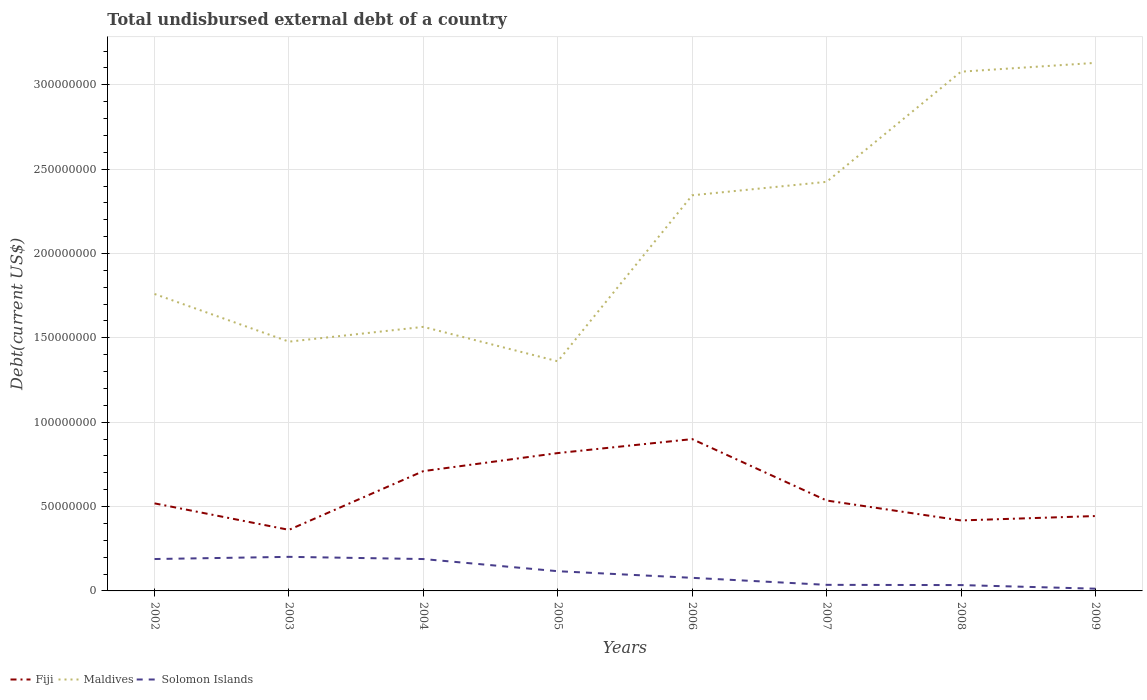Does the line corresponding to Maldives intersect with the line corresponding to Fiji?
Provide a succinct answer. No. Is the number of lines equal to the number of legend labels?
Keep it short and to the point. Yes. Across all years, what is the maximum total undisbursed external debt in Maldives?
Offer a very short reply. 1.36e+08. What is the total total undisbursed external debt in Solomon Islands in the graph?
Provide a short and direct response. -1.30e+06. What is the difference between the highest and the second highest total undisbursed external debt in Maldives?
Keep it short and to the point. 1.77e+08. Is the total undisbursed external debt in Maldives strictly greater than the total undisbursed external debt in Fiji over the years?
Give a very brief answer. No. How many lines are there?
Offer a very short reply. 3. What is the difference between two consecutive major ticks on the Y-axis?
Your answer should be very brief. 5.00e+07. Are the values on the major ticks of Y-axis written in scientific E-notation?
Keep it short and to the point. No. Does the graph contain grids?
Your response must be concise. Yes. What is the title of the graph?
Ensure brevity in your answer.  Total undisbursed external debt of a country. What is the label or title of the Y-axis?
Provide a short and direct response. Debt(current US$). What is the Debt(current US$) in Fiji in 2002?
Provide a succinct answer. 5.19e+07. What is the Debt(current US$) in Maldives in 2002?
Your answer should be very brief. 1.76e+08. What is the Debt(current US$) in Solomon Islands in 2002?
Offer a terse response. 1.89e+07. What is the Debt(current US$) of Fiji in 2003?
Keep it short and to the point. 3.62e+07. What is the Debt(current US$) in Maldives in 2003?
Make the answer very short. 1.48e+08. What is the Debt(current US$) of Solomon Islands in 2003?
Make the answer very short. 2.02e+07. What is the Debt(current US$) in Fiji in 2004?
Offer a very short reply. 7.10e+07. What is the Debt(current US$) in Maldives in 2004?
Offer a terse response. 1.57e+08. What is the Debt(current US$) of Solomon Islands in 2004?
Keep it short and to the point. 1.89e+07. What is the Debt(current US$) of Fiji in 2005?
Keep it short and to the point. 8.17e+07. What is the Debt(current US$) of Maldives in 2005?
Make the answer very short. 1.36e+08. What is the Debt(current US$) of Solomon Islands in 2005?
Your response must be concise. 1.17e+07. What is the Debt(current US$) of Fiji in 2006?
Keep it short and to the point. 9.00e+07. What is the Debt(current US$) in Maldives in 2006?
Keep it short and to the point. 2.35e+08. What is the Debt(current US$) of Solomon Islands in 2006?
Your response must be concise. 7.76e+06. What is the Debt(current US$) in Fiji in 2007?
Provide a succinct answer. 5.36e+07. What is the Debt(current US$) of Maldives in 2007?
Give a very brief answer. 2.42e+08. What is the Debt(current US$) of Solomon Islands in 2007?
Your answer should be compact. 3.60e+06. What is the Debt(current US$) of Fiji in 2008?
Provide a succinct answer. 4.18e+07. What is the Debt(current US$) in Maldives in 2008?
Offer a terse response. 3.08e+08. What is the Debt(current US$) of Solomon Islands in 2008?
Provide a short and direct response. 3.46e+06. What is the Debt(current US$) of Fiji in 2009?
Provide a succinct answer. 4.44e+07. What is the Debt(current US$) in Maldives in 2009?
Keep it short and to the point. 3.13e+08. What is the Debt(current US$) of Solomon Islands in 2009?
Keep it short and to the point. 1.32e+06. Across all years, what is the maximum Debt(current US$) of Fiji?
Provide a succinct answer. 9.00e+07. Across all years, what is the maximum Debt(current US$) of Maldives?
Your answer should be very brief. 3.13e+08. Across all years, what is the maximum Debt(current US$) in Solomon Islands?
Your answer should be very brief. 2.02e+07. Across all years, what is the minimum Debt(current US$) in Fiji?
Your answer should be very brief. 3.62e+07. Across all years, what is the minimum Debt(current US$) of Maldives?
Ensure brevity in your answer.  1.36e+08. Across all years, what is the minimum Debt(current US$) in Solomon Islands?
Ensure brevity in your answer.  1.32e+06. What is the total Debt(current US$) in Fiji in the graph?
Ensure brevity in your answer.  4.71e+08. What is the total Debt(current US$) of Maldives in the graph?
Offer a very short reply. 1.71e+09. What is the total Debt(current US$) in Solomon Islands in the graph?
Offer a very short reply. 8.58e+07. What is the difference between the Debt(current US$) in Fiji in 2002 and that in 2003?
Your answer should be compact. 1.57e+07. What is the difference between the Debt(current US$) of Maldives in 2002 and that in 2003?
Your answer should be compact. 2.83e+07. What is the difference between the Debt(current US$) of Solomon Islands in 2002 and that in 2003?
Your response must be concise. -1.30e+06. What is the difference between the Debt(current US$) of Fiji in 2002 and that in 2004?
Offer a terse response. -1.91e+07. What is the difference between the Debt(current US$) of Maldives in 2002 and that in 2004?
Provide a succinct answer. 1.95e+07. What is the difference between the Debt(current US$) of Solomon Islands in 2002 and that in 2004?
Offer a very short reply. 9000. What is the difference between the Debt(current US$) in Fiji in 2002 and that in 2005?
Your answer should be compact. -2.98e+07. What is the difference between the Debt(current US$) of Maldives in 2002 and that in 2005?
Provide a short and direct response. 3.99e+07. What is the difference between the Debt(current US$) in Solomon Islands in 2002 and that in 2005?
Ensure brevity in your answer.  7.22e+06. What is the difference between the Debt(current US$) in Fiji in 2002 and that in 2006?
Make the answer very short. -3.81e+07. What is the difference between the Debt(current US$) in Maldives in 2002 and that in 2006?
Your answer should be compact. -5.85e+07. What is the difference between the Debt(current US$) in Solomon Islands in 2002 and that in 2006?
Provide a short and direct response. 1.11e+07. What is the difference between the Debt(current US$) of Fiji in 2002 and that in 2007?
Offer a very short reply. -1.69e+06. What is the difference between the Debt(current US$) of Maldives in 2002 and that in 2007?
Provide a short and direct response. -6.65e+07. What is the difference between the Debt(current US$) in Solomon Islands in 2002 and that in 2007?
Make the answer very short. 1.53e+07. What is the difference between the Debt(current US$) in Fiji in 2002 and that in 2008?
Offer a very short reply. 1.01e+07. What is the difference between the Debt(current US$) of Maldives in 2002 and that in 2008?
Offer a very short reply. -1.32e+08. What is the difference between the Debt(current US$) of Solomon Islands in 2002 and that in 2008?
Ensure brevity in your answer.  1.54e+07. What is the difference between the Debt(current US$) in Fiji in 2002 and that in 2009?
Offer a very short reply. 7.51e+06. What is the difference between the Debt(current US$) in Maldives in 2002 and that in 2009?
Give a very brief answer. -1.37e+08. What is the difference between the Debt(current US$) of Solomon Islands in 2002 and that in 2009?
Keep it short and to the point. 1.76e+07. What is the difference between the Debt(current US$) in Fiji in 2003 and that in 2004?
Offer a very short reply. -3.48e+07. What is the difference between the Debt(current US$) in Maldives in 2003 and that in 2004?
Make the answer very short. -8.77e+06. What is the difference between the Debt(current US$) in Solomon Islands in 2003 and that in 2004?
Make the answer very short. 1.30e+06. What is the difference between the Debt(current US$) in Fiji in 2003 and that in 2005?
Your answer should be compact. -4.55e+07. What is the difference between the Debt(current US$) in Maldives in 2003 and that in 2005?
Keep it short and to the point. 1.16e+07. What is the difference between the Debt(current US$) in Solomon Islands in 2003 and that in 2005?
Make the answer very short. 8.52e+06. What is the difference between the Debt(current US$) of Fiji in 2003 and that in 2006?
Your response must be concise. -5.38e+07. What is the difference between the Debt(current US$) in Maldives in 2003 and that in 2006?
Make the answer very short. -8.68e+07. What is the difference between the Debt(current US$) of Solomon Islands in 2003 and that in 2006?
Provide a short and direct response. 1.24e+07. What is the difference between the Debt(current US$) of Fiji in 2003 and that in 2007?
Give a very brief answer. -1.74e+07. What is the difference between the Debt(current US$) of Maldives in 2003 and that in 2007?
Ensure brevity in your answer.  -9.47e+07. What is the difference between the Debt(current US$) in Solomon Islands in 2003 and that in 2007?
Provide a short and direct response. 1.66e+07. What is the difference between the Debt(current US$) of Fiji in 2003 and that in 2008?
Provide a succinct answer. -5.58e+06. What is the difference between the Debt(current US$) of Maldives in 2003 and that in 2008?
Ensure brevity in your answer.  -1.60e+08. What is the difference between the Debt(current US$) in Solomon Islands in 2003 and that in 2008?
Provide a succinct answer. 1.67e+07. What is the difference between the Debt(current US$) of Fiji in 2003 and that in 2009?
Your answer should be very brief. -8.18e+06. What is the difference between the Debt(current US$) in Maldives in 2003 and that in 2009?
Offer a very short reply. -1.65e+08. What is the difference between the Debt(current US$) of Solomon Islands in 2003 and that in 2009?
Give a very brief answer. 1.89e+07. What is the difference between the Debt(current US$) in Fiji in 2004 and that in 2005?
Your response must be concise. -1.07e+07. What is the difference between the Debt(current US$) in Maldives in 2004 and that in 2005?
Keep it short and to the point. 2.04e+07. What is the difference between the Debt(current US$) in Solomon Islands in 2004 and that in 2005?
Keep it short and to the point. 7.21e+06. What is the difference between the Debt(current US$) in Fiji in 2004 and that in 2006?
Offer a terse response. -1.90e+07. What is the difference between the Debt(current US$) in Maldives in 2004 and that in 2006?
Your answer should be compact. -7.80e+07. What is the difference between the Debt(current US$) of Solomon Islands in 2004 and that in 2006?
Your response must be concise. 1.11e+07. What is the difference between the Debt(current US$) in Fiji in 2004 and that in 2007?
Ensure brevity in your answer.  1.74e+07. What is the difference between the Debt(current US$) of Maldives in 2004 and that in 2007?
Your answer should be very brief. -8.60e+07. What is the difference between the Debt(current US$) of Solomon Islands in 2004 and that in 2007?
Make the answer very short. 1.53e+07. What is the difference between the Debt(current US$) in Fiji in 2004 and that in 2008?
Make the answer very short. 2.92e+07. What is the difference between the Debt(current US$) in Maldives in 2004 and that in 2008?
Offer a very short reply. -1.51e+08. What is the difference between the Debt(current US$) in Solomon Islands in 2004 and that in 2008?
Your response must be concise. 1.54e+07. What is the difference between the Debt(current US$) of Fiji in 2004 and that in 2009?
Your answer should be compact. 2.66e+07. What is the difference between the Debt(current US$) of Maldives in 2004 and that in 2009?
Keep it short and to the point. -1.56e+08. What is the difference between the Debt(current US$) in Solomon Islands in 2004 and that in 2009?
Offer a very short reply. 1.76e+07. What is the difference between the Debt(current US$) in Fiji in 2005 and that in 2006?
Make the answer very short. -8.28e+06. What is the difference between the Debt(current US$) of Maldives in 2005 and that in 2006?
Your answer should be compact. -9.84e+07. What is the difference between the Debt(current US$) in Solomon Islands in 2005 and that in 2006?
Keep it short and to the point. 3.92e+06. What is the difference between the Debt(current US$) in Fiji in 2005 and that in 2007?
Provide a succinct answer. 2.81e+07. What is the difference between the Debt(current US$) in Maldives in 2005 and that in 2007?
Keep it short and to the point. -1.06e+08. What is the difference between the Debt(current US$) in Solomon Islands in 2005 and that in 2007?
Keep it short and to the point. 8.08e+06. What is the difference between the Debt(current US$) of Fiji in 2005 and that in 2008?
Offer a very short reply. 3.99e+07. What is the difference between the Debt(current US$) in Maldives in 2005 and that in 2008?
Make the answer very short. -1.72e+08. What is the difference between the Debt(current US$) of Solomon Islands in 2005 and that in 2008?
Make the answer very short. 8.22e+06. What is the difference between the Debt(current US$) of Fiji in 2005 and that in 2009?
Provide a succinct answer. 3.73e+07. What is the difference between the Debt(current US$) in Maldives in 2005 and that in 2009?
Offer a terse response. -1.77e+08. What is the difference between the Debt(current US$) of Solomon Islands in 2005 and that in 2009?
Give a very brief answer. 1.04e+07. What is the difference between the Debt(current US$) in Fiji in 2006 and that in 2007?
Provide a short and direct response. 3.64e+07. What is the difference between the Debt(current US$) of Maldives in 2006 and that in 2007?
Keep it short and to the point. -7.98e+06. What is the difference between the Debt(current US$) in Solomon Islands in 2006 and that in 2007?
Your response must be concise. 4.16e+06. What is the difference between the Debt(current US$) of Fiji in 2006 and that in 2008?
Your answer should be very brief. 4.82e+07. What is the difference between the Debt(current US$) of Maldives in 2006 and that in 2008?
Provide a succinct answer. -7.33e+07. What is the difference between the Debt(current US$) of Solomon Islands in 2006 and that in 2008?
Provide a short and direct response. 4.30e+06. What is the difference between the Debt(current US$) of Fiji in 2006 and that in 2009?
Give a very brief answer. 4.56e+07. What is the difference between the Debt(current US$) of Maldives in 2006 and that in 2009?
Offer a terse response. -7.85e+07. What is the difference between the Debt(current US$) in Solomon Islands in 2006 and that in 2009?
Your answer should be compact. 6.44e+06. What is the difference between the Debt(current US$) of Fiji in 2007 and that in 2008?
Make the answer very short. 1.18e+07. What is the difference between the Debt(current US$) in Maldives in 2007 and that in 2008?
Make the answer very short. -6.53e+07. What is the difference between the Debt(current US$) in Solomon Islands in 2007 and that in 2008?
Offer a very short reply. 1.39e+05. What is the difference between the Debt(current US$) of Fiji in 2007 and that in 2009?
Your response must be concise. 9.20e+06. What is the difference between the Debt(current US$) of Maldives in 2007 and that in 2009?
Offer a very short reply. -7.05e+07. What is the difference between the Debt(current US$) of Solomon Islands in 2007 and that in 2009?
Your response must be concise. 2.28e+06. What is the difference between the Debt(current US$) of Fiji in 2008 and that in 2009?
Make the answer very short. -2.61e+06. What is the difference between the Debt(current US$) in Maldives in 2008 and that in 2009?
Your answer should be compact. -5.22e+06. What is the difference between the Debt(current US$) of Solomon Islands in 2008 and that in 2009?
Your answer should be compact. 2.14e+06. What is the difference between the Debt(current US$) in Fiji in 2002 and the Debt(current US$) in Maldives in 2003?
Offer a terse response. -9.59e+07. What is the difference between the Debt(current US$) of Fiji in 2002 and the Debt(current US$) of Solomon Islands in 2003?
Provide a succinct answer. 3.17e+07. What is the difference between the Debt(current US$) of Maldives in 2002 and the Debt(current US$) of Solomon Islands in 2003?
Provide a short and direct response. 1.56e+08. What is the difference between the Debt(current US$) in Fiji in 2002 and the Debt(current US$) in Maldives in 2004?
Make the answer very short. -1.05e+08. What is the difference between the Debt(current US$) in Fiji in 2002 and the Debt(current US$) in Solomon Islands in 2004?
Make the answer very short. 3.30e+07. What is the difference between the Debt(current US$) in Maldives in 2002 and the Debt(current US$) in Solomon Islands in 2004?
Keep it short and to the point. 1.57e+08. What is the difference between the Debt(current US$) of Fiji in 2002 and the Debt(current US$) of Maldives in 2005?
Make the answer very short. -8.42e+07. What is the difference between the Debt(current US$) of Fiji in 2002 and the Debt(current US$) of Solomon Islands in 2005?
Your answer should be very brief. 4.02e+07. What is the difference between the Debt(current US$) in Maldives in 2002 and the Debt(current US$) in Solomon Islands in 2005?
Your response must be concise. 1.64e+08. What is the difference between the Debt(current US$) in Fiji in 2002 and the Debt(current US$) in Maldives in 2006?
Make the answer very short. -1.83e+08. What is the difference between the Debt(current US$) in Fiji in 2002 and the Debt(current US$) in Solomon Islands in 2006?
Make the answer very short. 4.41e+07. What is the difference between the Debt(current US$) in Maldives in 2002 and the Debt(current US$) in Solomon Islands in 2006?
Your answer should be compact. 1.68e+08. What is the difference between the Debt(current US$) in Fiji in 2002 and the Debt(current US$) in Maldives in 2007?
Your answer should be compact. -1.91e+08. What is the difference between the Debt(current US$) of Fiji in 2002 and the Debt(current US$) of Solomon Islands in 2007?
Your answer should be compact. 4.83e+07. What is the difference between the Debt(current US$) of Maldives in 2002 and the Debt(current US$) of Solomon Islands in 2007?
Your answer should be compact. 1.72e+08. What is the difference between the Debt(current US$) in Fiji in 2002 and the Debt(current US$) in Maldives in 2008?
Your response must be concise. -2.56e+08. What is the difference between the Debt(current US$) of Fiji in 2002 and the Debt(current US$) of Solomon Islands in 2008?
Offer a very short reply. 4.84e+07. What is the difference between the Debt(current US$) of Maldives in 2002 and the Debt(current US$) of Solomon Islands in 2008?
Give a very brief answer. 1.73e+08. What is the difference between the Debt(current US$) of Fiji in 2002 and the Debt(current US$) of Maldives in 2009?
Your answer should be compact. -2.61e+08. What is the difference between the Debt(current US$) in Fiji in 2002 and the Debt(current US$) in Solomon Islands in 2009?
Keep it short and to the point. 5.06e+07. What is the difference between the Debt(current US$) of Maldives in 2002 and the Debt(current US$) of Solomon Islands in 2009?
Your answer should be compact. 1.75e+08. What is the difference between the Debt(current US$) of Fiji in 2003 and the Debt(current US$) of Maldives in 2004?
Make the answer very short. -1.20e+08. What is the difference between the Debt(current US$) in Fiji in 2003 and the Debt(current US$) in Solomon Islands in 2004?
Make the answer very short. 1.73e+07. What is the difference between the Debt(current US$) in Maldives in 2003 and the Debt(current US$) in Solomon Islands in 2004?
Offer a terse response. 1.29e+08. What is the difference between the Debt(current US$) of Fiji in 2003 and the Debt(current US$) of Maldives in 2005?
Provide a succinct answer. -9.99e+07. What is the difference between the Debt(current US$) of Fiji in 2003 and the Debt(current US$) of Solomon Islands in 2005?
Make the answer very short. 2.45e+07. What is the difference between the Debt(current US$) of Maldives in 2003 and the Debt(current US$) of Solomon Islands in 2005?
Provide a short and direct response. 1.36e+08. What is the difference between the Debt(current US$) in Fiji in 2003 and the Debt(current US$) in Maldives in 2006?
Keep it short and to the point. -1.98e+08. What is the difference between the Debt(current US$) of Fiji in 2003 and the Debt(current US$) of Solomon Islands in 2006?
Make the answer very short. 2.84e+07. What is the difference between the Debt(current US$) of Maldives in 2003 and the Debt(current US$) of Solomon Islands in 2006?
Your response must be concise. 1.40e+08. What is the difference between the Debt(current US$) in Fiji in 2003 and the Debt(current US$) in Maldives in 2007?
Make the answer very short. -2.06e+08. What is the difference between the Debt(current US$) in Fiji in 2003 and the Debt(current US$) in Solomon Islands in 2007?
Keep it short and to the point. 3.26e+07. What is the difference between the Debt(current US$) of Maldives in 2003 and the Debt(current US$) of Solomon Islands in 2007?
Make the answer very short. 1.44e+08. What is the difference between the Debt(current US$) in Fiji in 2003 and the Debt(current US$) in Maldives in 2008?
Give a very brief answer. -2.72e+08. What is the difference between the Debt(current US$) of Fiji in 2003 and the Debt(current US$) of Solomon Islands in 2008?
Provide a short and direct response. 3.27e+07. What is the difference between the Debt(current US$) of Maldives in 2003 and the Debt(current US$) of Solomon Islands in 2008?
Provide a succinct answer. 1.44e+08. What is the difference between the Debt(current US$) in Fiji in 2003 and the Debt(current US$) in Maldives in 2009?
Offer a terse response. -2.77e+08. What is the difference between the Debt(current US$) of Fiji in 2003 and the Debt(current US$) of Solomon Islands in 2009?
Offer a very short reply. 3.49e+07. What is the difference between the Debt(current US$) in Maldives in 2003 and the Debt(current US$) in Solomon Islands in 2009?
Your response must be concise. 1.46e+08. What is the difference between the Debt(current US$) of Fiji in 2004 and the Debt(current US$) of Maldives in 2005?
Provide a short and direct response. -6.51e+07. What is the difference between the Debt(current US$) in Fiji in 2004 and the Debt(current US$) in Solomon Islands in 2005?
Ensure brevity in your answer.  5.93e+07. What is the difference between the Debt(current US$) in Maldives in 2004 and the Debt(current US$) in Solomon Islands in 2005?
Provide a short and direct response. 1.45e+08. What is the difference between the Debt(current US$) of Fiji in 2004 and the Debt(current US$) of Maldives in 2006?
Make the answer very short. -1.63e+08. What is the difference between the Debt(current US$) of Fiji in 2004 and the Debt(current US$) of Solomon Islands in 2006?
Provide a succinct answer. 6.33e+07. What is the difference between the Debt(current US$) of Maldives in 2004 and the Debt(current US$) of Solomon Islands in 2006?
Offer a very short reply. 1.49e+08. What is the difference between the Debt(current US$) of Fiji in 2004 and the Debt(current US$) of Maldives in 2007?
Provide a short and direct response. -1.71e+08. What is the difference between the Debt(current US$) in Fiji in 2004 and the Debt(current US$) in Solomon Islands in 2007?
Provide a succinct answer. 6.74e+07. What is the difference between the Debt(current US$) of Maldives in 2004 and the Debt(current US$) of Solomon Islands in 2007?
Offer a very short reply. 1.53e+08. What is the difference between the Debt(current US$) in Fiji in 2004 and the Debt(current US$) in Maldives in 2008?
Your answer should be compact. -2.37e+08. What is the difference between the Debt(current US$) of Fiji in 2004 and the Debt(current US$) of Solomon Islands in 2008?
Give a very brief answer. 6.76e+07. What is the difference between the Debt(current US$) in Maldives in 2004 and the Debt(current US$) in Solomon Islands in 2008?
Ensure brevity in your answer.  1.53e+08. What is the difference between the Debt(current US$) in Fiji in 2004 and the Debt(current US$) in Maldives in 2009?
Keep it short and to the point. -2.42e+08. What is the difference between the Debt(current US$) of Fiji in 2004 and the Debt(current US$) of Solomon Islands in 2009?
Your response must be concise. 6.97e+07. What is the difference between the Debt(current US$) of Maldives in 2004 and the Debt(current US$) of Solomon Islands in 2009?
Make the answer very short. 1.55e+08. What is the difference between the Debt(current US$) of Fiji in 2005 and the Debt(current US$) of Maldives in 2006?
Offer a terse response. -1.53e+08. What is the difference between the Debt(current US$) in Fiji in 2005 and the Debt(current US$) in Solomon Islands in 2006?
Your response must be concise. 7.39e+07. What is the difference between the Debt(current US$) of Maldives in 2005 and the Debt(current US$) of Solomon Islands in 2006?
Your response must be concise. 1.28e+08. What is the difference between the Debt(current US$) in Fiji in 2005 and the Debt(current US$) in Maldives in 2007?
Your answer should be compact. -1.61e+08. What is the difference between the Debt(current US$) of Fiji in 2005 and the Debt(current US$) of Solomon Islands in 2007?
Ensure brevity in your answer.  7.81e+07. What is the difference between the Debt(current US$) in Maldives in 2005 and the Debt(current US$) in Solomon Islands in 2007?
Keep it short and to the point. 1.33e+08. What is the difference between the Debt(current US$) of Fiji in 2005 and the Debt(current US$) of Maldives in 2008?
Your answer should be very brief. -2.26e+08. What is the difference between the Debt(current US$) in Fiji in 2005 and the Debt(current US$) in Solomon Islands in 2008?
Your response must be concise. 7.82e+07. What is the difference between the Debt(current US$) in Maldives in 2005 and the Debt(current US$) in Solomon Islands in 2008?
Your response must be concise. 1.33e+08. What is the difference between the Debt(current US$) in Fiji in 2005 and the Debt(current US$) in Maldives in 2009?
Provide a succinct answer. -2.31e+08. What is the difference between the Debt(current US$) in Fiji in 2005 and the Debt(current US$) in Solomon Islands in 2009?
Offer a terse response. 8.04e+07. What is the difference between the Debt(current US$) of Maldives in 2005 and the Debt(current US$) of Solomon Islands in 2009?
Keep it short and to the point. 1.35e+08. What is the difference between the Debt(current US$) of Fiji in 2006 and the Debt(current US$) of Maldives in 2007?
Offer a very short reply. -1.53e+08. What is the difference between the Debt(current US$) of Fiji in 2006 and the Debt(current US$) of Solomon Islands in 2007?
Give a very brief answer. 8.64e+07. What is the difference between the Debt(current US$) of Maldives in 2006 and the Debt(current US$) of Solomon Islands in 2007?
Provide a succinct answer. 2.31e+08. What is the difference between the Debt(current US$) in Fiji in 2006 and the Debt(current US$) in Maldives in 2008?
Offer a very short reply. -2.18e+08. What is the difference between the Debt(current US$) in Fiji in 2006 and the Debt(current US$) in Solomon Islands in 2008?
Make the answer very short. 8.65e+07. What is the difference between the Debt(current US$) in Maldives in 2006 and the Debt(current US$) in Solomon Islands in 2008?
Make the answer very short. 2.31e+08. What is the difference between the Debt(current US$) in Fiji in 2006 and the Debt(current US$) in Maldives in 2009?
Your response must be concise. -2.23e+08. What is the difference between the Debt(current US$) of Fiji in 2006 and the Debt(current US$) of Solomon Islands in 2009?
Your answer should be very brief. 8.87e+07. What is the difference between the Debt(current US$) in Maldives in 2006 and the Debt(current US$) in Solomon Islands in 2009?
Offer a very short reply. 2.33e+08. What is the difference between the Debt(current US$) of Fiji in 2007 and the Debt(current US$) of Maldives in 2008?
Offer a terse response. -2.54e+08. What is the difference between the Debt(current US$) of Fiji in 2007 and the Debt(current US$) of Solomon Islands in 2008?
Provide a succinct answer. 5.01e+07. What is the difference between the Debt(current US$) in Maldives in 2007 and the Debt(current US$) in Solomon Islands in 2008?
Give a very brief answer. 2.39e+08. What is the difference between the Debt(current US$) of Fiji in 2007 and the Debt(current US$) of Maldives in 2009?
Make the answer very short. -2.59e+08. What is the difference between the Debt(current US$) in Fiji in 2007 and the Debt(current US$) in Solomon Islands in 2009?
Keep it short and to the point. 5.23e+07. What is the difference between the Debt(current US$) of Maldives in 2007 and the Debt(current US$) of Solomon Islands in 2009?
Your response must be concise. 2.41e+08. What is the difference between the Debt(current US$) of Fiji in 2008 and the Debt(current US$) of Maldives in 2009?
Offer a very short reply. -2.71e+08. What is the difference between the Debt(current US$) of Fiji in 2008 and the Debt(current US$) of Solomon Islands in 2009?
Your answer should be compact. 4.05e+07. What is the difference between the Debt(current US$) of Maldives in 2008 and the Debt(current US$) of Solomon Islands in 2009?
Provide a short and direct response. 3.06e+08. What is the average Debt(current US$) in Fiji per year?
Offer a very short reply. 5.88e+07. What is the average Debt(current US$) of Maldives per year?
Offer a very short reply. 2.14e+08. What is the average Debt(current US$) of Solomon Islands per year?
Ensure brevity in your answer.  1.07e+07. In the year 2002, what is the difference between the Debt(current US$) in Fiji and Debt(current US$) in Maldives?
Make the answer very short. -1.24e+08. In the year 2002, what is the difference between the Debt(current US$) of Fiji and Debt(current US$) of Solomon Islands?
Make the answer very short. 3.30e+07. In the year 2002, what is the difference between the Debt(current US$) in Maldives and Debt(current US$) in Solomon Islands?
Your response must be concise. 1.57e+08. In the year 2003, what is the difference between the Debt(current US$) of Fiji and Debt(current US$) of Maldives?
Give a very brief answer. -1.12e+08. In the year 2003, what is the difference between the Debt(current US$) in Fiji and Debt(current US$) in Solomon Islands?
Your answer should be compact. 1.60e+07. In the year 2003, what is the difference between the Debt(current US$) of Maldives and Debt(current US$) of Solomon Islands?
Your answer should be very brief. 1.28e+08. In the year 2004, what is the difference between the Debt(current US$) in Fiji and Debt(current US$) in Maldives?
Make the answer very short. -8.55e+07. In the year 2004, what is the difference between the Debt(current US$) of Fiji and Debt(current US$) of Solomon Islands?
Offer a terse response. 5.21e+07. In the year 2004, what is the difference between the Debt(current US$) of Maldives and Debt(current US$) of Solomon Islands?
Your answer should be compact. 1.38e+08. In the year 2005, what is the difference between the Debt(current US$) of Fiji and Debt(current US$) of Maldives?
Make the answer very short. -5.44e+07. In the year 2005, what is the difference between the Debt(current US$) in Fiji and Debt(current US$) in Solomon Islands?
Your answer should be compact. 7.00e+07. In the year 2005, what is the difference between the Debt(current US$) in Maldives and Debt(current US$) in Solomon Islands?
Provide a short and direct response. 1.24e+08. In the year 2006, what is the difference between the Debt(current US$) in Fiji and Debt(current US$) in Maldives?
Offer a terse response. -1.45e+08. In the year 2006, what is the difference between the Debt(current US$) in Fiji and Debt(current US$) in Solomon Islands?
Ensure brevity in your answer.  8.22e+07. In the year 2006, what is the difference between the Debt(current US$) in Maldives and Debt(current US$) in Solomon Islands?
Your answer should be compact. 2.27e+08. In the year 2007, what is the difference between the Debt(current US$) in Fiji and Debt(current US$) in Maldives?
Keep it short and to the point. -1.89e+08. In the year 2007, what is the difference between the Debt(current US$) in Fiji and Debt(current US$) in Solomon Islands?
Your response must be concise. 5.00e+07. In the year 2007, what is the difference between the Debt(current US$) in Maldives and Debt(current US$) in Solomon Islands?
Keep it short and to the point. 2.39e+08. In the year 2008, what is the difference between the Debt(current US$) of Fiji and Debt(current US$) of Maldives?
Your answer should be very brief. -2.66e+08. In the year 2008, what is the difference between the Debt(current US$) in Fiji and Debt(current US$) in Solomon Islands?
Your answer should be compact. 3.83e+07. In the year 2008, what is the difference between the Debt(current US$) in Maldives and Debt(current US$) in Solomon Islands?
Make the answer very short. 3.04e+08. In the year 2009, what is the difference between the Debt(current US$) of Fiji and Debt(current US$) of Maldives?
Give a very brief answer. -2.69e+08. In the year 2009, what is the difference between the Debt(current US$) in Fiji and Debt(current US$) in Solomon Islands?
Make the answer very short. 4.31e+07. In the year 2009, what is the difference between the Debt(current US$) of Maldives and Debt(current US$) of Solomon Islands?
Your answer should be very brief. 3.12e+08. What is the ratio of the Debt(current US$) of Fiji in 2002 to that in 2003?
Your answer should be very brief. 1.43. What is the ratio of the Debt(current US$) of Maldives in 2002 to that in 2003?
Offer a very short reply. 1.19. What is the ratio of the Debt(current US$) in Solomon Islands in 2002 to that in 2003?
Your response must be concise. 0.94. What is the ratio of the Debt(current US$) of Fiji in 2002 to that in 2004?
Your answer should be compact. 0.73. What is the ratio of the Debt(current US$) in Maldives in 2002 to that in 2004?
Offer a terse response. 1.12. What is the ratio of the Debt(current US$) of Fiji in 2002 to that in 2005?
Ensure brevity in your answer.  0.64. What is the ratio of the Debt(current US$) of Maldives in 2002 to that in 2005?
Make the answer very short. 1.29. What is the ratio of the Debt(current US$) in Solomon Islands in 2002 to that in 2005?
Provide a succinct answer. 1.62. What is the ratio of the Debt(current US$) in Fiji in 2002 to that in 2006?
Ensure brevity in your answer.  0.58. What is the ratio of the Debt(current US$) of Maldives in 2002 to that in 2006?
Offer a very short reply. 0.75. What is the ratio of the Debt(current US$) of Solomon Islands in 2002 to that in 2006?
Keep it short and to the point. 2.43. What is the ratio of the Debt(current US$) of Fiji in 2002 to that in 2007?
Your answer should be compact. 0.97. What is the ratio of the Debt(current US$) of Maldives in 2002 to that in 2007?
Provide a succinct answer. 0.73. What is the ratio of the Debt(current US$) of Solomon Islands in 2002 to that in 2007?
Offer a terse response. 5.25. What is the ratio of the Debt(current US$) in Fiji in 2002 to that in 2008?
Your response must be concise. 1.24. What is the ratio of the Debt(current US$) of Maldives in 2002 to that in 2008?
Offer a terse response. 0.57. What is the ratio of the Debt(current US$) of Solomon Islands in 2002 to that in 2008?
Give a very brief answer. 5.46. What is the ratio of the Debt(current US$) of Fiji in 2002 to that in 2009?
Ensure brevity in your answer.  1.17. What is the ratio of the Debt(current US$) of Maldives in 2002 to that in 2009?
Offer a terse response. 0.56. What is the ratio of the Debt(current US$) in Solomon Islands in 2002 to that in 2009?
Offer a terse response. 14.28. What is the ratio of the Debt(current US$) in Fiji in 2003 to that in 2004?
Offer a terse response. 0.51. What is the ratio of the Debt(current US$) in Maldives in 2003 to that in 2004?
Your answer should be very brief. 0.94. What is the ratio of the Debt(current US$) of Solomon Islands in 2003 to that in 2004?
Provide a short and direct response. 1.07. What is the ratio of the Debt(current US$) in Fiji in 2003 to that in 2005?
Keep it short and to the point. 0.44. What is the ratio of the Debt(current US$) in Maldives in 2003 to that in 2005?
Your answer should be very brief. 1.09. What is the ratio of the Debt(current US$) in Solomon Islands in 2003 to that in 2005?
Make the answer very short. 1.73. What is the ratio of the Debt(current US$) in Fiji in 2003 to that in 2006?
Ensure brevity in your answer.  0.4. What is the ratio of the Debt(current US$) in Maldives in 2003 to that in 2006?
Offer a terse response. 0.63. What is the ratio of the Debt(current US$) in Solomon Islands in 2003 to that in 2006?
Ensure brevity in your answer.  2.6. What is the ratio of the Debt(current US$) in Fiji in 2003 to that in 2007?
Offer a very short reply. 0.68. What is the ratio of the Debt(current US$) of Maldives in 2003 to that in 2007?
Keep it short and to the point. 0.61. What is the ratio of the Debt(current US$) in Solomon Islands in 2003 to that in 2007?
Your answer should be very brief. 5.61. What is the ratio of the Debt(current US$) in Fiji in 2003 to that in 2008?
Keep it short and to the point. 0.87. What is the ratio of the Debt(current US$) of Maldives in 2003 to that in 2008?
Your response must be concise. 0.48. What is the ratio of the Debt(current US$) in Solomon Islands in 2003 to that in 2008?
Your answer should be compact. 5.83. What is the ratio of the Debt(current US$) in Fiji in 2003 to that in 2009?
Your answer should be very brief. 0.82. What is the ratio of the Debt(current US$) of Maldives in 2003 to that in 2009?
Provide a succinct answer. 0.47. What is the ratio of the Debt(current US$) in Solomon Islands in 2003 to that in 2009?
Offer a very short reply. 15.26. What is the ratio of the Debt(current US$) in Fiji in 2004 to that in 2005?
Your answer should be very brief. 0.87. What is the ratio of the Debt(current US$) of Maldives in 2004 to that in 2005?
Your response must be concise. 1.15. What is the ratio of the Debt(current US$) in Solomon Islands in 2004 to that in 2005?
Your answer should be very brief. 1.62. What is the ratio of the Debt(current US$) in Fiji in 2004 to that in 2006?
Keep it short and to the point. 0.79. What is the ratio of the Debt(current US$) of Maldives in 2004 to that in 2006?
Provide a short and direct response. 0.67. What is the ratio of the Debt(current US$) of Solomon Islands in 2004 to that in 2006?
Provide a succinct answer. 2.43. What is the ratio of the Debt(current US$) in Fiji in 2004 to that in 2007?
Provide a short and direct response. 1.33. What is the ratio of the Debt(current US$) of Maldives in 2004 to that in 2007?
Provide a short and direct response. 0.65. What is the ratio of the Debt(current US$) in Solomon Islands in 2004 to that in 2007?
Your response must be concise. 5.25. What is the ratio of the Debt(current US$) in Fiji in 2004 to that in 2008?
Your response must be concise. 1.7. What is the ratio of the Debt(current US$) in Maldives in 2004 to that in 2008?
Offer a very short reply. 0.51. What is the ratio of the Debt(current US$) in Solomon Islands in 2004 to that in 2008?
Provide a succinct answer. 5.46. What is the ratio of the Debt(current US$) of Maldives in 2004 to that in 2009?
Provide a short and direct response. 0.5. What is the ratio of the Debt(current US$) in Solomon Islands in 2004 to that in 2009?
Your answer should be compact. 14.27. What is the ratio of the Debt(current US$) in Fiji in 2005 to that in 2006?
Provide a succinct answer. 0.91. What is the ratio of the Debt(current US$) of Maldives in 2005 to that in 2006?
Offer a very short reply. 0.58. What is the ratio of the Debt(current US$) of Solomon Islands in 2005 to that in 2006?
Give a very brief answer. 1.5. What is the ratio of the Debt(current US$) in Fiji in 2005 to that in 2007?
Ensure brevity in your answer.  1.52. What is the ratio of the Debt(current US$) of Maldives in 2005 to that in 2007?
Offer a very short reply. 0.56. What is the ratio of the Debt(current US$) of Solomon Islands in 2005 to that in 2007?
Offer a very short reply. 3.24. What is the ratio of the Debt(current US$) in Fiji in 2005 to that in 2008?
Provide a succinct answer. 1.96. What is the ratio of the Debt(current US$) of Maldives in 2005 to that in 2008?
Give a very brief answer. 0.44. What is the ratio of the Debt(current US$) in Solomon Islands in 2005 to that in 2008?
Offer a terse response. 3.37. What is the ratio of the Debt(current US$) of Fiji in 2005 to that in 2009?
Make the answer very short. 1.84. What is the ratio of the Debt(current US$) of Maldives in 2005 to that in 2009?
Your answer should be very brief. 0.43. What is the ratio of the Debt(current US$) of Solomon Islands in 2005 to that in 2009?
Offer a terse response. 8.83. What is the ratio of the Debt(current US$) of Fiji in 2006 to that in 2007?
Your answer should be very brief. 1.68. What is the ratio of the Debt(current US$) of Maldives in 2006 to that in 2007?
Provide a short and direct response. 0.97. What is the ratio of the Debt(current US$) of Solomon Islands in 2006 to that in 2007?
Your answer should be compact. 2.16. What is the ratio of the Debt(current US$) in Fiji in 2006 to that in 2008?
Make the answer very short. 2.15. What is the ratio of the Debt(current US$) in Maldives in 2006 to that in 2008?
Provide a succinct answer. 0.76. What is the ratio of the Debt(current US$) in Solomon Islands in 2006 to that in 2008?
Provide a short and direct response. 2.24. What is the ratio of the Debt(current US$) of Fiji in 2006 to that in 2009?
Offer a terse response. 2.03. What is the ratio of the Debt(current US$) in Maldives in 2006 to that in 2009?
Your answer should be compact. 0.75. What is the ratio of the Debt(current US$) of Solomon Islands in 2006 to that in 2009?
Give a very brief answer. 5.86. What is the ratio of the Debt(current US$) of Fiji in 2007 to that in 2008?
Your answer should be compact. 1.28. What is the ratio of the Debt(current US$) of Maldives in 2007 to that in 2008?
Provide a short and direct response. 0.79. What is the ratio of the Debt(current US$) in Solomon Islands in 2007 to that in 2008?
Make the answer very short. 1.04. What is the ratio of the Debt(current US$) of Fiji in 2007 to that in 2009?
Offer a very short reply. 1.21. What is the ratio of the Debt(current US$) of Maldives in 2007 to that in 2009?
Give a very brief answer. 0.77. What is the ratio of the Debt(current US$) in Solomon Islands in 2007 to that in 2009?
Ensure brevity in your answer.  2.72. What is the ratio of the Debt(current US$) of Fiji in 2008 to that in 2009?
Ensure brevity in your answer.  0.94. What is the ratio of the Debt(current US$) in Maldives in 2008 to that in 2009?
Provide a short and direct response. 0.98. What is the ratio of the Debt(current US$) of Solomon Islands in 2008 to that in 2009?
Offer a very short reply. 2.62. What is the difference between the highest and the second highest Debt(current US$) in Fiji?
Give a very brief answer. 8.28e+06. What is the difference between the highest and the second highest Debt(current US$) of Maldives?
Your answer should be compact. 5.22e+06. What is the difference between the highest and the second highest Debt(current US$) of Solomon Islands?
Provide a succinct answer. 1.30e+06. What is the difference between the highest and the lowest Debt(current US$) in Fiji?
Ensure brevity in your answer.  5.38e+07. What is the difference between the highest and the lowest Debt(current US$) of Maldives?
Give a very brief answer. 1.77e+08. What is the difference between the highest and the lowest Debt(current US$) of Solomon Islands?
Ensure brevity in your answer.  1.89e+07. 